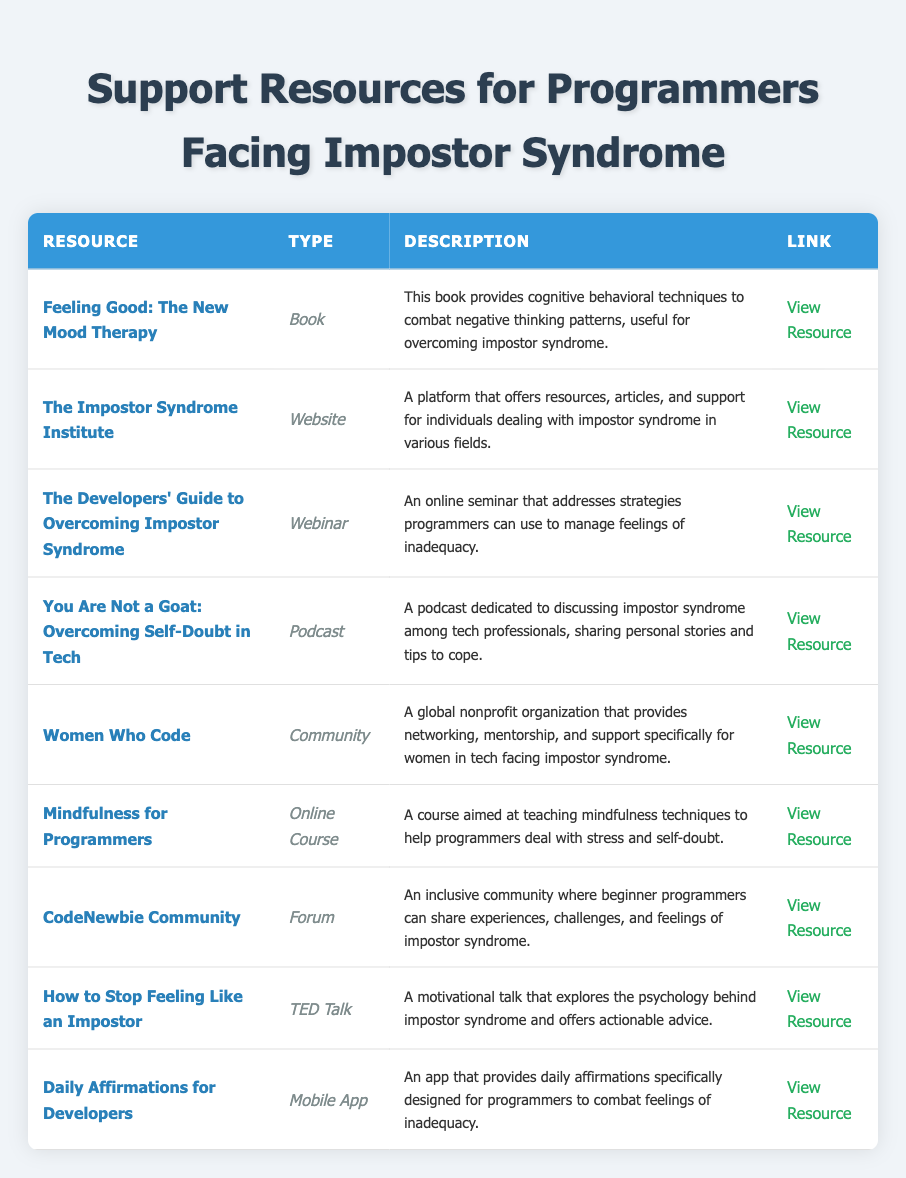What is the resource type of "Feeling Good: The New Mood Therapy"? The table lists "Feeling Good: The New Mood Therapy" under the "Type" column, which indicates it is categorized as a "Book."
Answer: Book How many resources in the table are podcasts? Upon checking the "Type" column in the table, there is one entry that is categorized as a "Podcast," which is "You Are Not a Goat: Overcoming Self-Doubt in Tech."
Answer: 1 Is there a resource specifically aimed at women in tech? By reviewing the descriptions, "Women Who Code" is mentioned as a community providing support specifically for women in tech, confirming the existence of such a resource.
Answer: Yes What type of support does the "CodeNewbie Community" provide? The description of "CodeNewbie Community" indicates that it serves as a forum for beginner programmers to share experiences and talk about impostor syndrome, thus providing peer support.
Answer: Forum How many online courses are mentioned in the resources? The table includes one resource labeled as an "Online Course," which is "Mindfulness for Programmers."
Answer: 1 Which resource is authored by David D. Burns? The table identifies "Feeling Good: The New Mood Therapy" and lists David D. Burns as the author in the "Author" field.
Answer: Feeling Good: The New Mood Therapy Which resource has the URL https://impostorsyndrome.com/? The table shows "The Impostor Syndrome Institute" listed with the URL https://impostorsyndrome.com/, directly matching the provided URL.
Answer: The Impostor Syndrome Institute What is the combined number of webinars and podcasts listed in the table? The table features one webinar ("The Developers' Guide to Overcoming Impostor Syndrome") plus one podcast ("You Are Not a Goat: Overcoming Self-Doubt in Tech"), summing to two resources total.
Answer: 2 How many resources focus on mobile applications? The only mobile app listed in the table is "Daily Affirmations for Developers," indicating there is just one resource in this category.
Answer: 1 Who is the host of the webinar? The description of the webinar "The Developers' Guide to Overcoming Impostor Syndrome" clearly states that it is hosted by "TechWellness."
Answer: TechWellness Which resource offers cognitive behavioral techniques? The table indicates that "Feeling Good: The New Mood Therapy" provides cognitive behavioral techniques to help combat negative thinking patterns related to impostor syndrome.
Answer: Feeling Good: The New Mood Therapy 